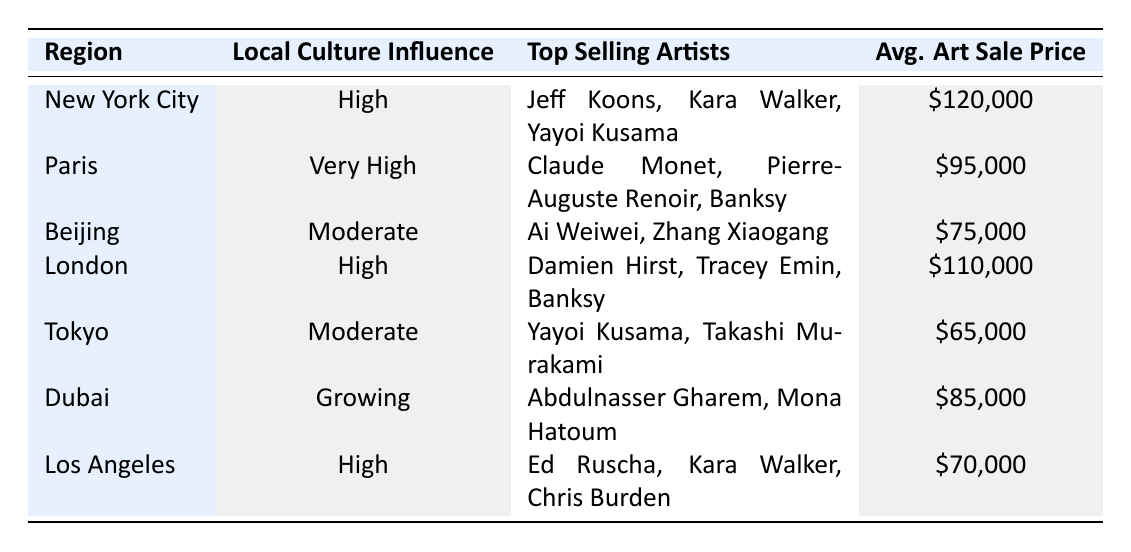What is the average art sale price in New York City? The table provides a specific value for average art sale price in New York City, which is listed as $120,000.
Answer: $120,000 Which region has the highest local culture influence? The table indicates that Paris has a "Very High" local culture influence, which is the highest category listed.
Answer: Paris How many artists are listed as top-selling artists in Tokyo? The table lists two top-selling artists for Tokyo: Yayoi Kusama and Takashi Murakami.
Answer: 2 What is the difference in average art sale price between London and Los Angeles? The average art sale price in London is $110,000, and in Los Angeles, it is $70,000. The difference is $110,000 - $70,000 = $40,000.
Answer: $40,000 Is the local culture influence in Beijing higher than in Dubai? The table shows Beijing with a "Moderate" influence and Dubai with a "Growing" influence, meaning Beijing's is higher than Dubai’s.
Answer: Yes What is the average of the average art sale prices for the regions with high local culture influence? The average prices for regions with high influence are New York City ($120,000), London ($110,000), and Los Angeles ($70,000). Adding these gives $120,000 + $110,000 + $70,000 = $300,000. Dividing by 3 gives an average of $300,000 / 3 = $100,000.
Answer: $100,000 Which region has the lowest average art sale price? The table lists the average art sale price for each region, where Tokyo has the lowest at $65,000.
Answer: Tokyo Are there any notable art events listed for Beijing? Yes, the table specifies two notable art events in Beijing: the Beijing Biennale and Art Beijing.
Answer: Yes What key cultural factor is shared by both New York City and London? Both New York City and London emphasize cultural diversity in their key cultural factors, as indicated in the table.
Answer: Cultural diversity List the top-selling artists from Paris. The table provides the names of the top-selling artists in Paris, which are Claude Monet, Pierre-Auguste Renoir, and Banksy.
Answer: Claude Monet, Pierre-Auguste Renoir, Banksy 